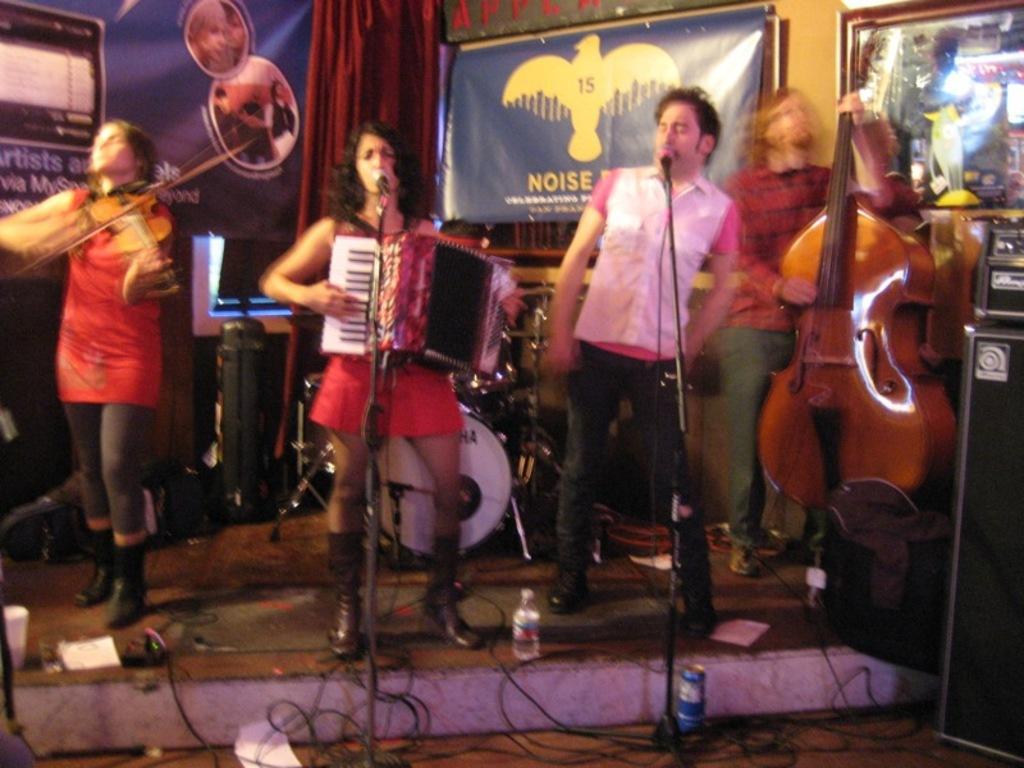Could you give a brief overview of what you see in this image? This picture is clicked inside. On the right there is a person standing on the ground and seems to be playing guitar and there is a man standing on the ground and a woman wearing a red color dress, standing on the ground and playing a musical instrument. On the left there is another person standing on the ground and playing violin. In the foreground we can see the microphones are attached to the stand and there are some objects placed on the ground. In the background there are some musical instruments and the banners hanging on the wall and we can see a curtain. 